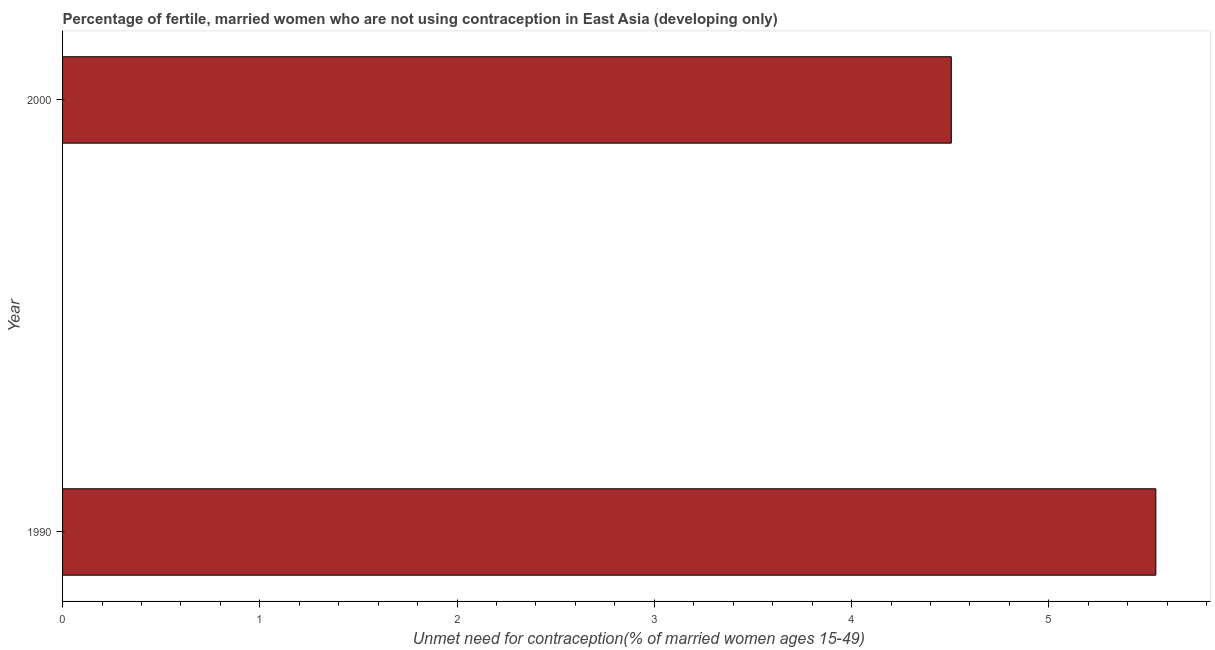Does the graph contain grids?
Give a very brief answer. No. What is the title of the graph?
Offer a very short reply. Percentage of fertile, married women who are not using contraception in East Asia (developing only). What is the label or title of the X-axis?
Give a very brief answer.  Unmet need for contraception(% of married women ages 15-49). What is the label or title of the Y-axis?
Your response must be concise. Year. What is the number of married women who are not using contraception in 1990?
Keep it short and to the point. 5.54. Across all years, what is the maximum number of married women who are not using contraception?
Your answer should be compact. 5.54. Across all years, what is the minimum number of married women who are not using contraception?
Your answer should be compact. 4.51. In which year was the number of married women who are not using contraception maximum?
Your response must be concise. 1990. What is the sum of the number of married women who are not using contraception?
Provide a short and direct response. 10.05. What is the difference between the number of married women who are not using contraception in 1990 and 2000?
Ensure brevity in your answer.  1.04. What is the average number of married women who are not using contraception per year?
Give a very brief answer. 5.02. What is the median number of married women who are not using contraception?
Ensure brevity in your answer.  5.02. In how many years, is the number of married women who are not using contraception greater than 3.4 %?
Your answer should be compact. 2. Do a majority of the years between 1990 and 2000 (inclusive) have number of married women who are not using contraception greater than 2.2 %?
Your response must be concise. Yes. What is the ratio of the number of married women who are not using contraception in 1990 to that in 2000?
Make the answer very short. 1.23. In how many years, is the number of married women who are not using contraception greater than the average number of married women who are not using contraception taken over all years?
Offer a terse response. 1. Are all the bars in the graph horizontal?
Offer a very short reply. Yes. What is the difference between two consecutive major ticks on the X-axis?
Keep it short and to the point. 1. Are the values on the major ticks of X-axis written in scientific E-notation?
Offer a very short reply. No. What is the  Unmet need for contraception(% of married women ages 15-49) in 1990?
Ensure brevity in your answer.  5.54. What is the  Unmet need for contraception(% of married women ages 15-49) in 2000?
Provide a short and direct response. 4.51. What is the difference between the  Unmet need for contraception(% of married women ages 15-49) in 1990 and 2000?
Provide a succinct answer. 1.04. What is the ratio of the  Unmet need for contraception(% of married women ages 15-49) in 1990 to that in 2000?
Offer a terse response. 1.23. 